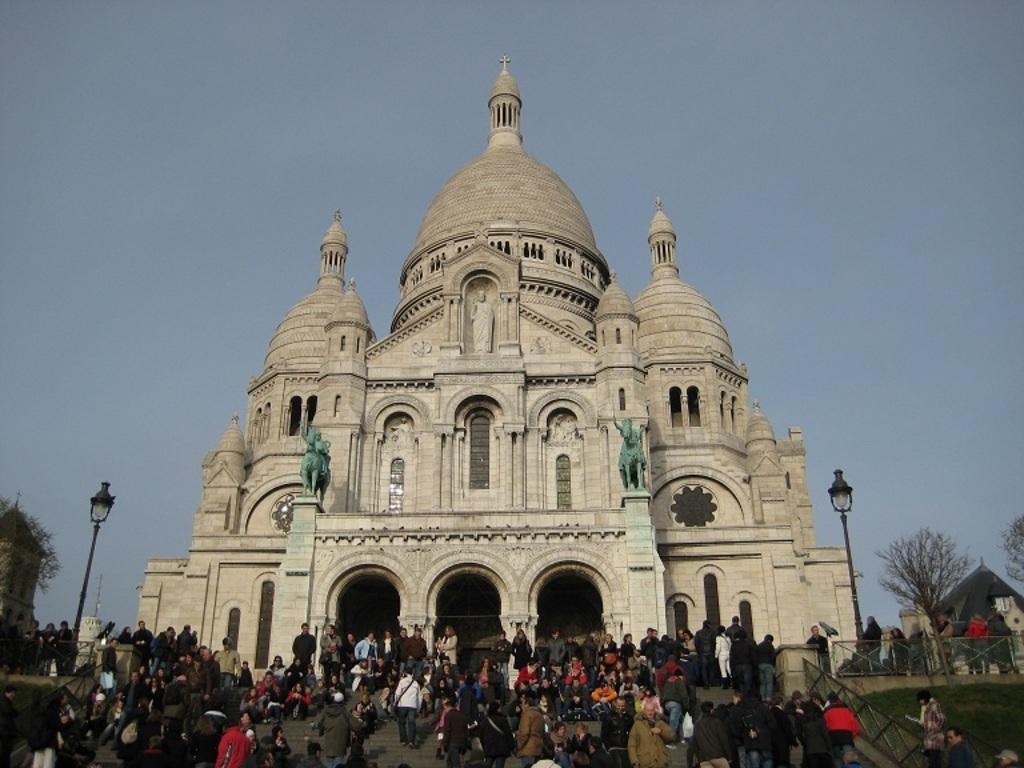What are the people in the image doing? The people in the image are walking on the stairs. What structures can be seen in the image? There are light poles and a stone building in the image. What type of vegetation is present in the image? There are trees in the image. What is visible in the background of the image? The sky is plain in the background of the image. How does the bomb affect the people in the image? There is no bomb present in the image, so it does not affect the people. Is there a rainstorm occurring in the image? There is no rainstorm present in the image; the sky is plain in the background. 